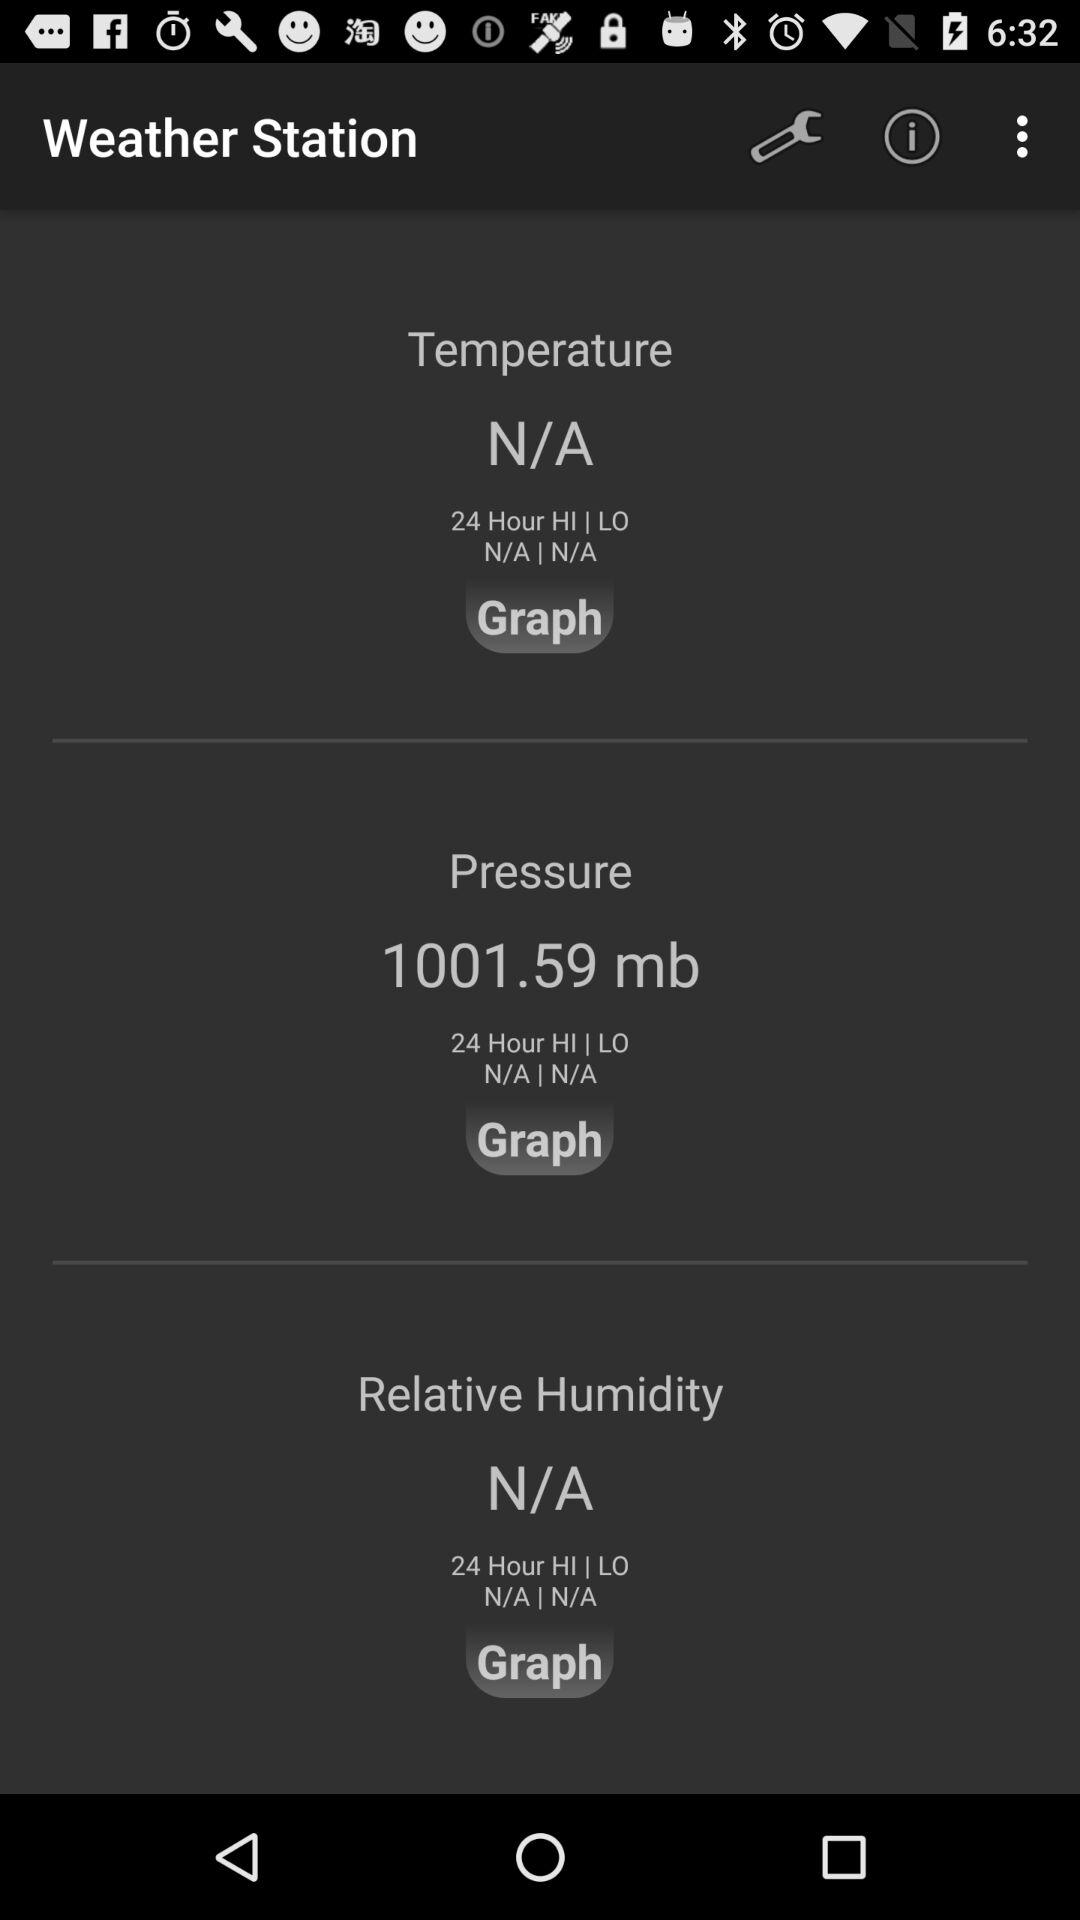How many items have a 24 Hour HI | LO value of N/A?
Answer the question using a single word or phrase. 3 